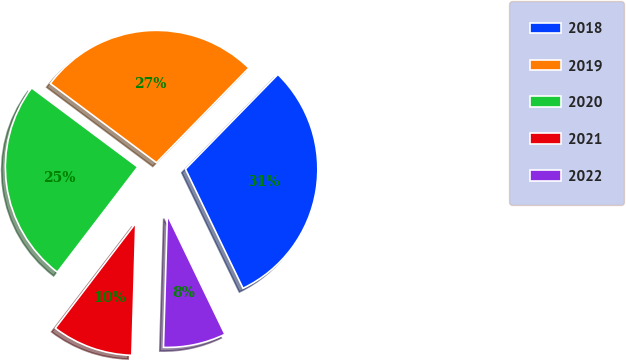Convert chart. <chart><loc_0><loc_0><loc_500><loc_500><pie_chart><fcel>2018<fcel>2019<fcel>2020<fcel>2021<fcel>2022<nl><fcel>30.53%<fcel>27.1%<fcel>24.81%<fcel>9.92%<fcel>7.63%<nl></chart> 